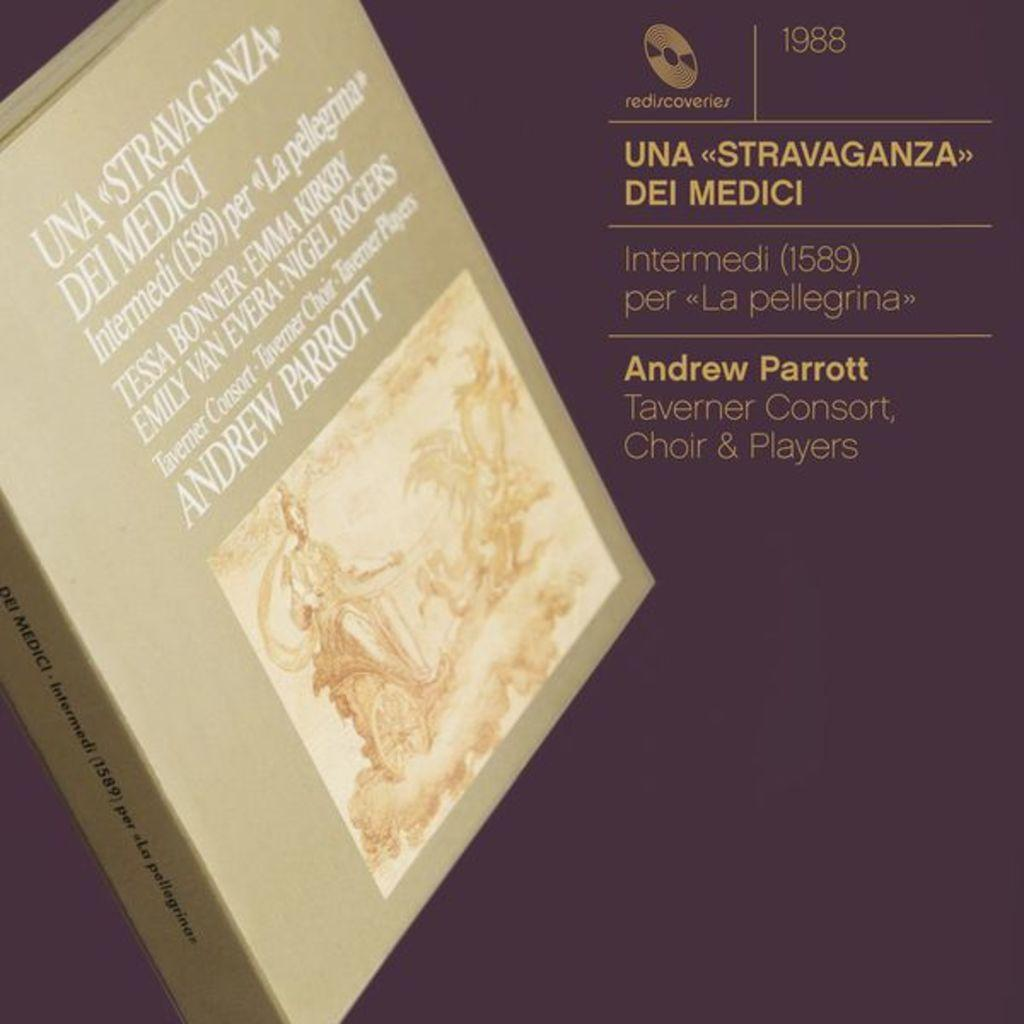<image>
Describe the image concisely. A book cover lists Andrew Parrott and others. 